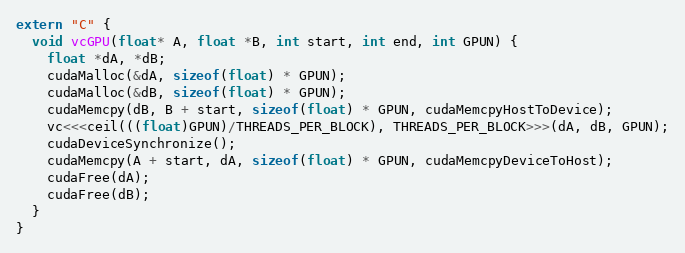Convert code to text. <code><loc_0><loc_0><loc_500><loc_500><_Cuda_>extern "C" {
  void vcGPU(float* A, float *B, int start, int end, int GPUN) {
    float *dA, *dB;
    cudaMalloc(&dA, sizeof(float) * GPUN);
    cudaMalloc(&dB, sizeof(float) * GPUN);
    cudaMemcpy(dB, B + start, sizeof(float) * GPUN, cudaMemcpyHostToDevice);
    vc<<<ceil(((float)GPUN)/THREADS_PER_BLOCK), THREADS_PER_BLOCK>>>(dA, dB, GPUN);
    cudaDeviceSynchronize();
    cudaMemcpy(A + start, dA, sizeof(float) * GPUN, cudaMemcpyDeviceToHost);
    cudaFree(dA);
    cudaFree(dB);
  }
}
</code> 